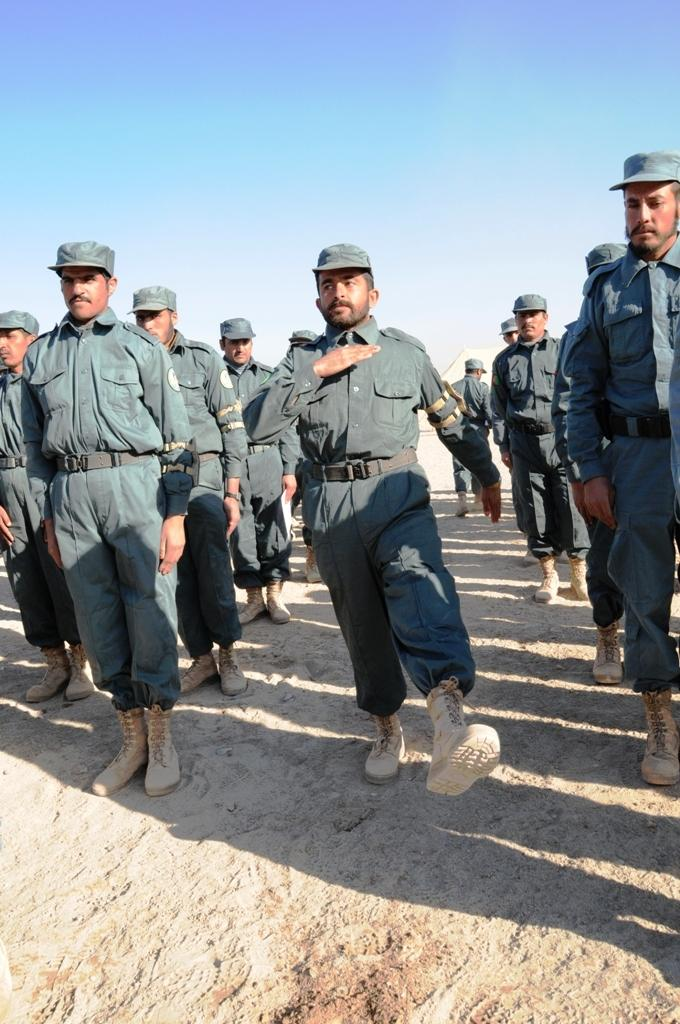What are the people in the image wearing? The people in the image are wearing uniforms. What is one person doing in the image? One man is standing and lifting his leg. What can be seen in the background of the image? The sky is visible in the background of the image. What type of wool is being used to make the plane visible in the image? There is no plane visible in the image, and therefore no wool is being used to make it. 